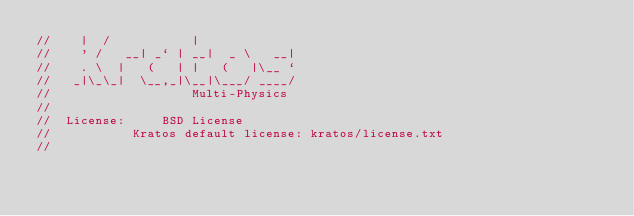<code> <loc_0><loc_0><loc_500><loc_500><_C++_>//    |  /           |
//    ' /   __| _` | __|  _ \   __|
//    . \  |   (   | |   (   |\__ `
//   _|\_\_|  \__,_|\__|\___/ ____/
//                   Multi-Physics
//
//  License:		 BSD License
//					 Kratos default license: kratos/license.txt
//</code> 